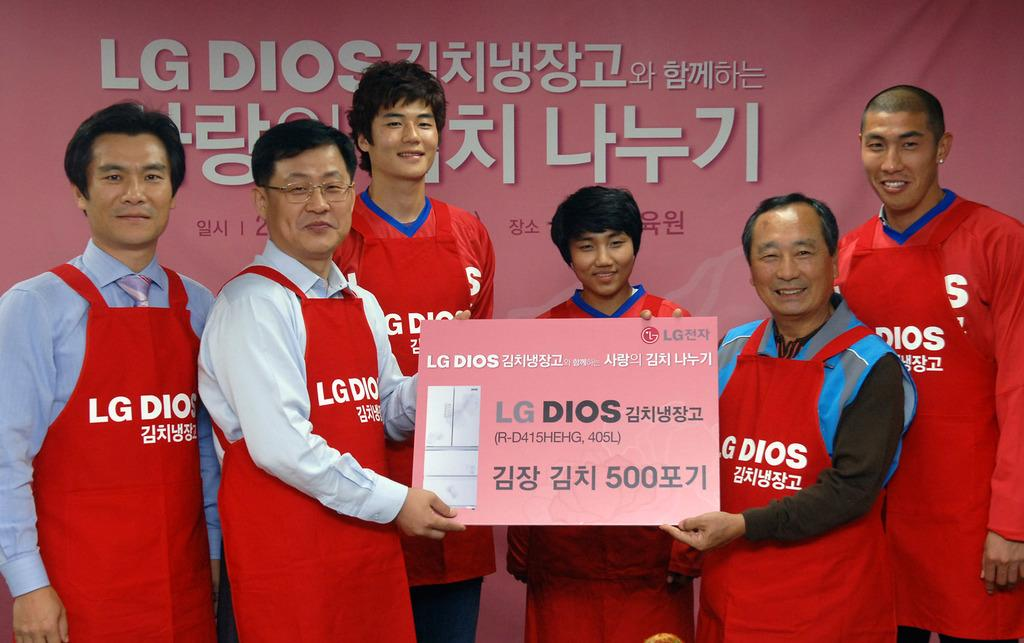What is the main subject of the image? The main subject of the image is a group of men. What are the men doing in the image? The men are collectively holding a card. What can be identified from the card in the image? The card belongs to LG company. What else is visible in the image besides the men and the card? There is a banner visible in the image. What type of knowledge does the dad in the image have about clouds? There is no dad or mention of clouds in the image; it features a group of men holding a card from LG company. 